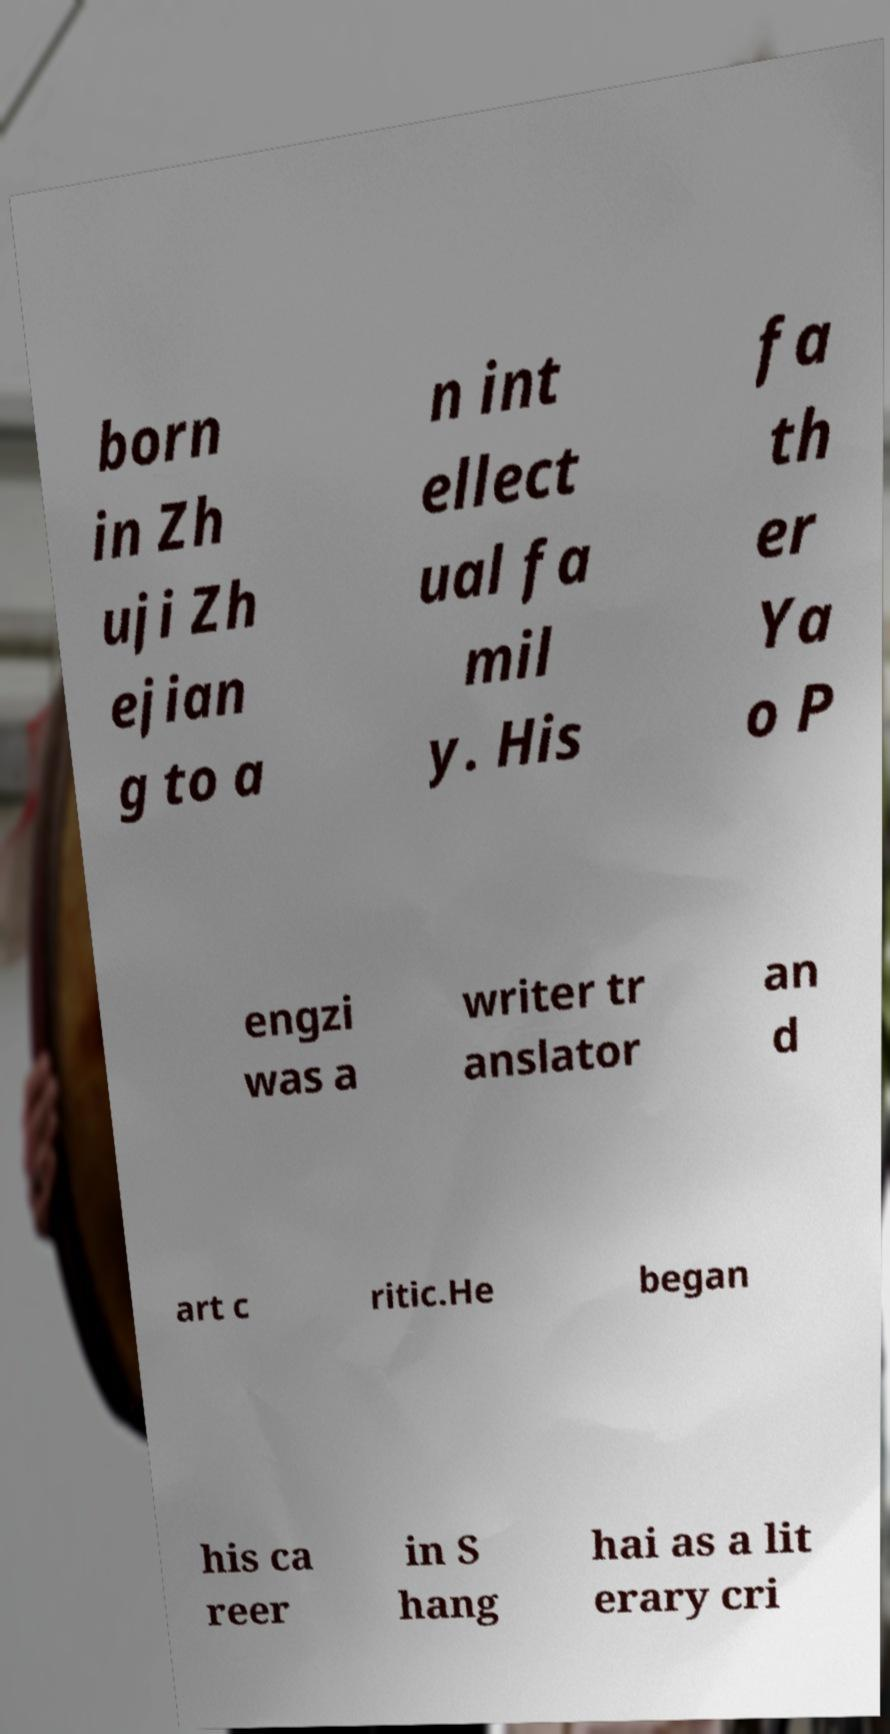Can you accurately transcribe the text from the provided image for me? born in Zh uji Zh ejian g to a n int ellect ual fa mil y. His fa th er Ya o P engzi was a writer tr anslator an d art c ritic.He began his ca reer in S hang hai as a lit erary cri 